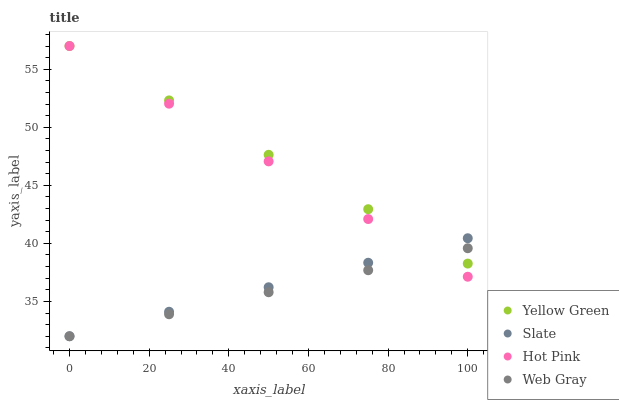Does Web Gray have the minimum area under the curve?
Answer yes or no. Yes. Does Yellow Green have the maximum area under the curve?
Answer yes or no. Yes. Does Hot Pink have the minimum area under the curve?
Answer yes or no. No. Does Hot Pink have the maximum area under the curve?
Answer yes or no. No. Is Web Gray the smoothest?
Answer yes or no. Yes. Is Hot Pink the roughest?
Answer yes or no. Yes. Is Hot Pink the smoothest?
Answer yes or no. No. Is Web Gray the roughest?
Answer yes or no. No. Does Slate have the lowest value?
Answer yes or no. Yes. Does Hot Pink have the lowest value?
Answer yes or no. No. Does Yellow Green have the highest value?
Answer yes or no. Yes. Does Web Gray have the highest value?
Answer yes or no. No. Does Hot Pink intersect Yellow Green?
Answer yes or no. Yes. Is Hot Pink less than Yellow Green?
Answer yes or no. No. Is Hot Pink greater than Yellow Green?
Answer yes or no. No. 